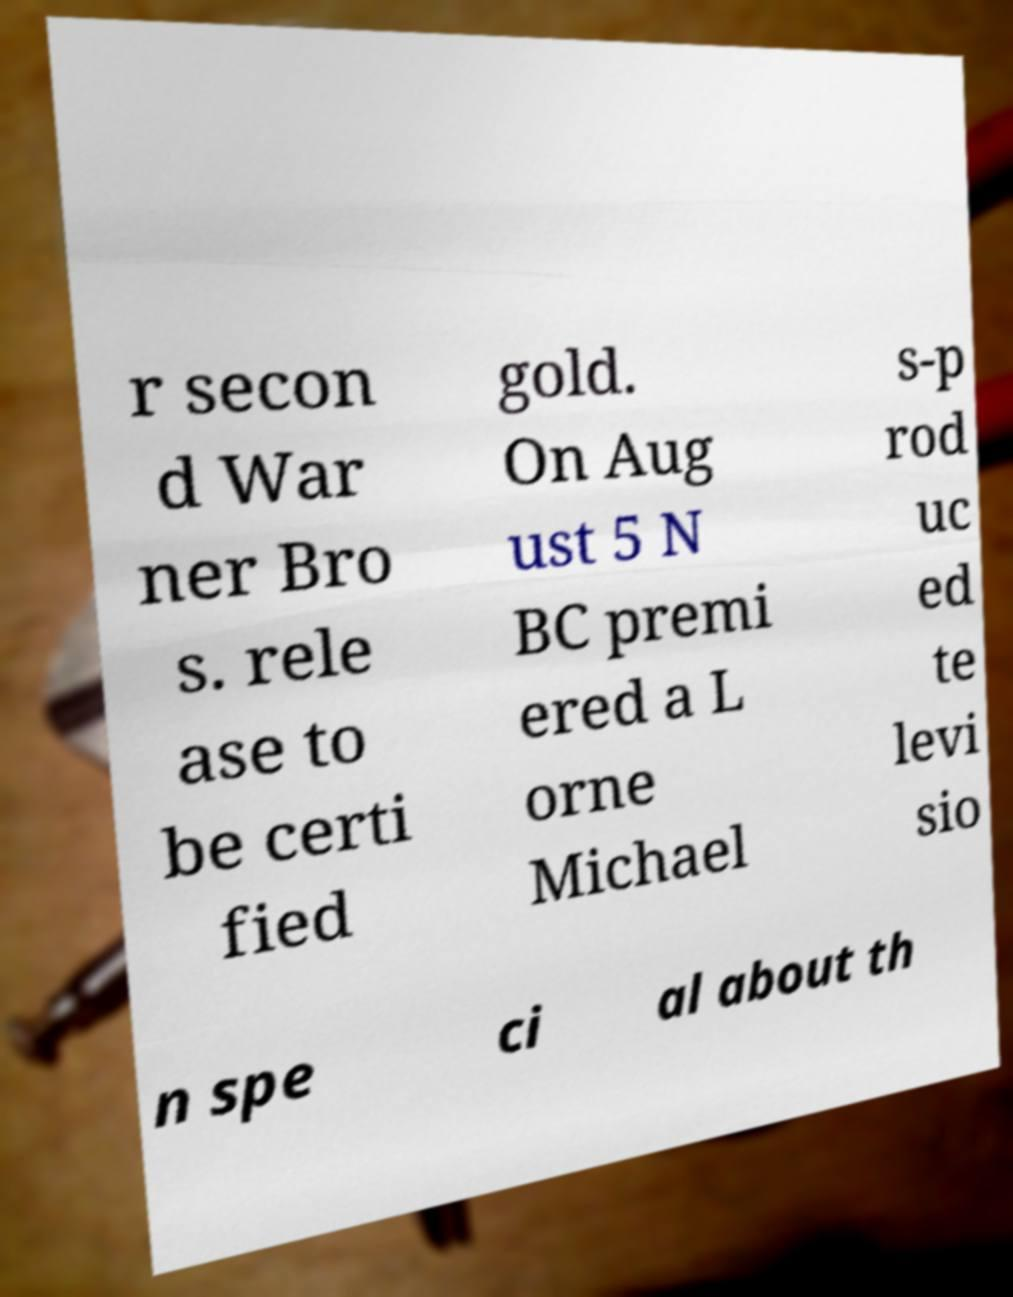I need the written content from this picture converted into text. Can you do that? r secon d War ner Bro s. rele ase to be certi fied gold. On Aug ust 5 N BC premi ered a L orne Michael s-p rod uc ed te levi sio n spe ci al about th 